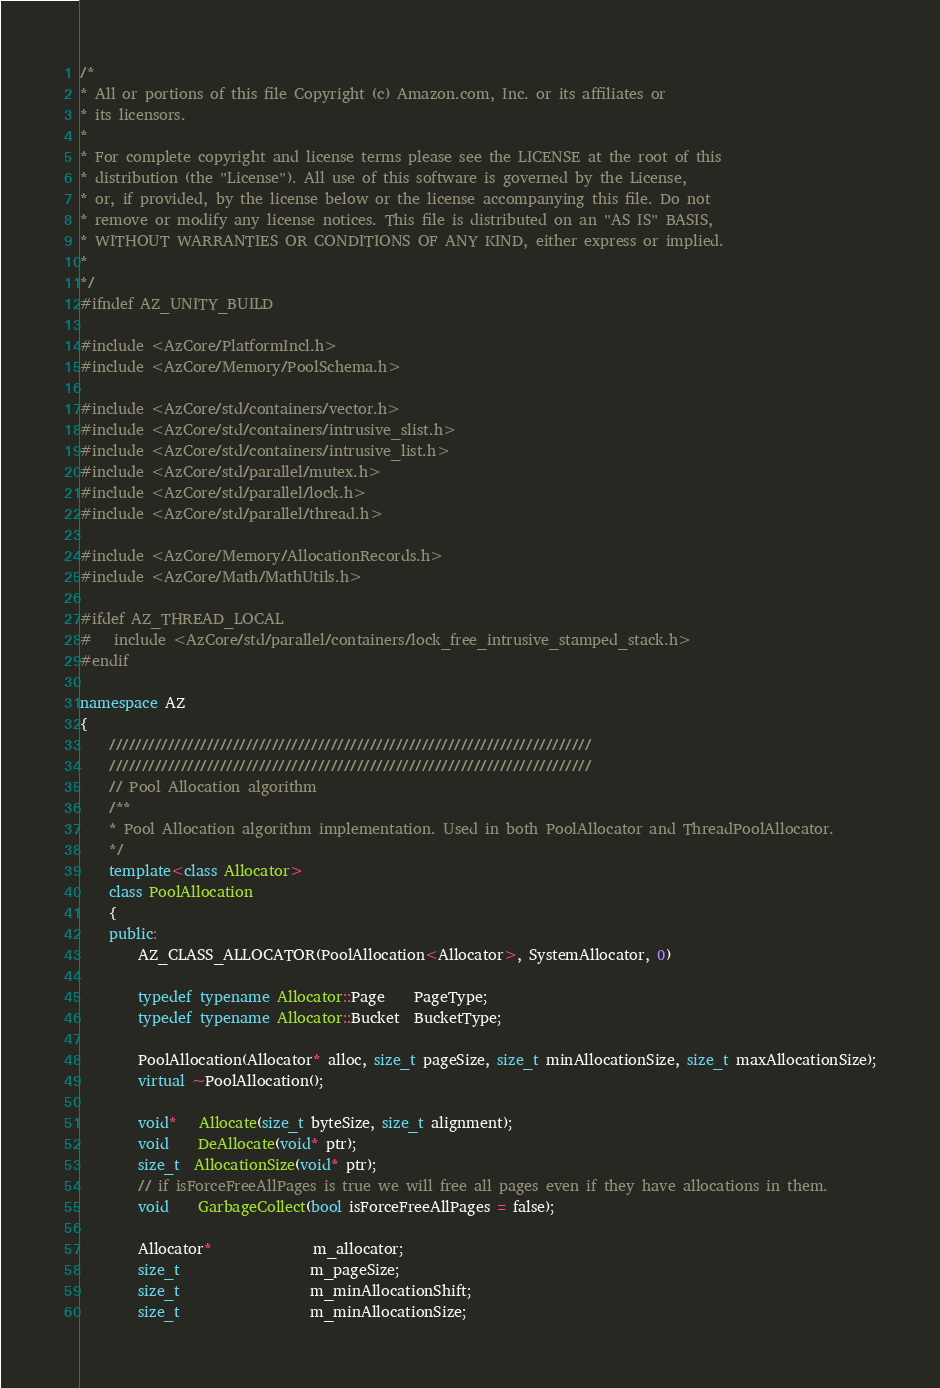Convert code to text. <code><loc_0><loc_0><loc_500><loc_500><_C++_>/*
* All or portions of this file Copyright (c) Amazon.com, Inc. or its affiliates or
* its licensors.
*
* For complete copyright and license terms please see the LICENSE at the root of this
* distribution (the "License"). All use of this software is governed by the License,
* or, if provided, by the license below or the license accompanying this file. Do not
* remove or modify any license notices. This file is distributed on an "AS IS" BASIS,
* WITHOUT WARRANTIES OR CONDITIONS OF ANY KIND, either express or implied.
*
*/
#ifndef AZ_UNITY_BUILD

#include <AzCore/PlatformIncl.h>
#include <AzCore/Memory/PoolSchema.h>

#include <AzCore/std/containers/vector.h>
#include <AzCore/std/containers/intrusive_slist.h>
#include <AzCore/std/containers/intrusive_list.h>
#include <AzCore/std/parallel/mutex.h>
#include <AzCore/std/parallel/lock.h>
#include <AzCore/std/parallel/thread.h>

#include <AzCore/Memory/AllocationRecords.h>
#include <AzCore/Math/MathUtils.h>

#ifdef AZ_THREAD_LOCAL
#   include <AzCore/std/parallel/containers/lock_free_intrusive_stamped_stack.h>
#endif

namespace AZ
{
    //////////////////////////////////////////////////////////////////////////
    //////////////////////////////////////////////////////////////////////////
    // Pool Allocation algorithm
    /**
    * Pool Allocation algorithm implementation. Used in both PoolAllocator and ThreadPoolAllocator.
    */
    template<class Allocator>
    class PoolAllocation
    {
    public:
        AZ_CLASS_ALLOCATOR(PoolAllocation<Allocator>, SystemAllocator, 0)

        typedef typename Allocator::Page    PageType;
        typedef typename Allocator::Bucket  BucketType;

        PoolAllocation(Allocator* alloc, size_t pageSize, size_t minAllocationSize, size_t maxAllocationSize);
        virtual ~PoolAllocation();

        void*   Allocate(size_t byteSize, size_t alignment);
        void    DeAllocate(void* ptr);
        size_t  AllocationSize(void* ptr);
        // if isForceFreeAllPages is true we will free all pages even if they have allocations in them.
        void    GarbageCollect(bool isForceFreeAllPages = false);

        Allocator*              m_allocator;
        size_t                  m_pageSize;
        size_t                  m_minAllocationShift;
        size_t                  m_minAllocationSize;</code> 